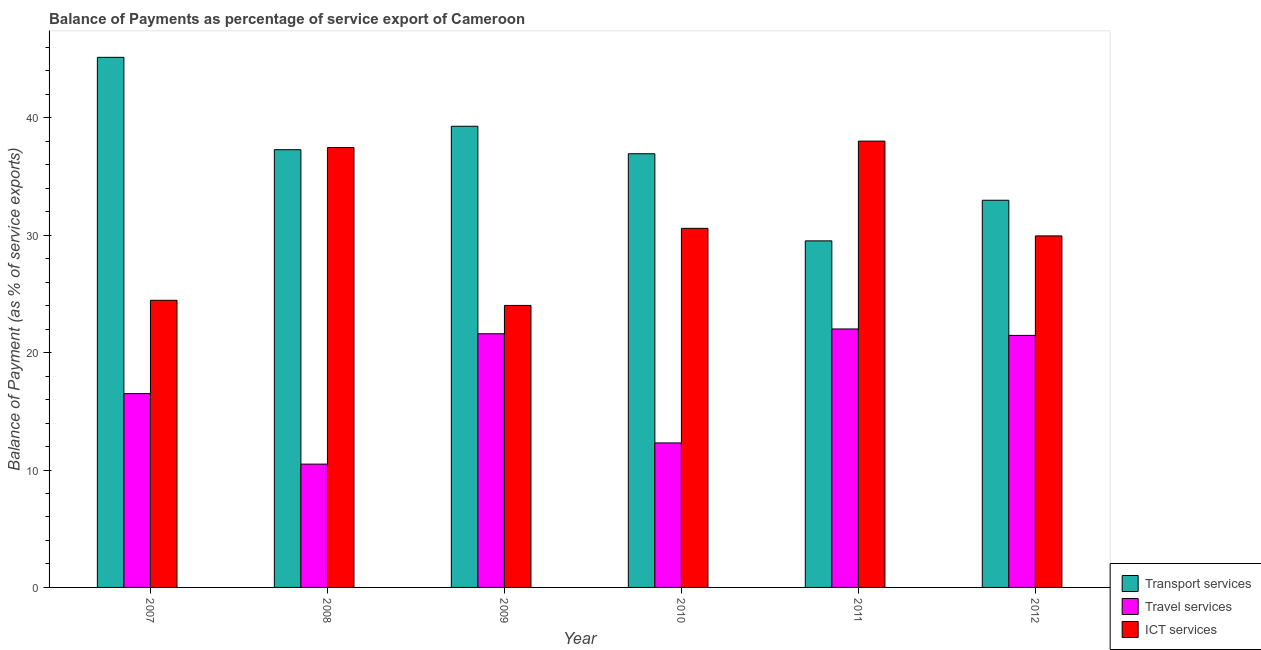How many different coloured bars are there?
Offer a terse response. 3. How many groups of bars are there?
Ensure brevity in your answer.  6. Are the number of bars per tick equal to the number of legend labels?
Make the answer very short. Yes. How many bars are there on the 2nd tick from the left?
Your response must be concise. 3. In how many cases, is the number of bars for a given year not equal to the number of legend labels?
Your answer should be compact. 0. What is the balance of payment of travel services in 2011?
Make the answer very short. 22.01. Across all years, what is the maximum balance of payment of travel services?
Offer a terse response. 22.01. Across all years, what is the minimum balance of payment of ict services?
Make the answer very short. 24.02. In which year was the balance of payment of travel services maximum?
Ensure brevity in your answer.  2011. What is the total balance of payment of ict services in the graph?
Ensure brevity in your answer.  184.48. What is the difference between the balance of payment of travel services in 2007 and that in 2009?
Make the answer very short. -5.1. What is the difference between the balance of payment of travel services in 2007 and the balance of payment of ict services in 2011?
Your response must be concise. -5.51. What is the average balance of payment of travel services per year?
Give a very brief answer. 17.4. In the year 2007, what is the difference between the balance of payment of transport services and balance of payment of travel services?
Keep it short and to the point. 0. What is the ratio of the balance of payment of travel services in 2008 to that in 2011?
Provide a short and direct response. 0.48. Is the difference between the balance of payment of transport services in 2008 and 2010 greater than the difference between the balance of payment of travel services in 2008 and 2010?
Your response must be concise. No. What is the difference between the highest and the second highest balance of payment of travel services?
Keep it short and to the point. 0.41. What is the difference between the highest and the lowest balance of payment of ict services?
Give a very brief answer. 14. In how many years, is the balance of payment of transport services greater than the average balance of payment of transport services taken over all years?
Offer a terse response. 4. What does the 2nd bar from the left in 2007 represents?
Provide a short and direct response. Travel services. What does the 2nd bar from the right in 2012 represents?
Offer a very short reply. Travel services. Is it the case that in every year, the sum of the balance of payment of transport services and balance of payment of travel services is greater than the balance of payment of ict services?
Offer a terse response. Yes. How many legend labels are there?
Ensure brevity in your answer.  3. How are the legend labels stacked?
Make the answer very short. Vertical. What is the title of the graph?
Provide a short and direct response. Balance of Payments as percentage of service export of Cameroon. Does "Hydroelectric sources" appear as one of the legend labels in the graph?
Ensure brevity in your answer.  No. What is the label or title of the X-axis?
Give a very brief answer. Year. What is the label or title of the Y-axis?
Offer a terse response. Balance of Payment (as % of service exports). What is the Balance of Payment (as % of service exports) in Transport services in 2007?
Provide a short and direct response. 45.15. What is the Balance of Payment (as % of service exports) of Travel services in 2007?
Your response must be concise. 16.51. What is the Balance of Payment (as % of service exports) in ICT services in 2007?
Give a very brief answer. 24.46. What is the Balance of Payment (as % of service exports) of Transport services in 2008?
Offer a terse response. 37.28. What is the Balance of Payment (as % of service exports) in Travel services in 2008?
Your answer should be very brief. 10.5. What is the Balance of Payment (as % of service exports) in ICT services in 2008?
Your response must be concise. 37.47. What is the Balance of Payment (as % of service exports) of Transport services in 2009?
Ensure brevity in your answer.  39.28. What is the Balance of Payment (as % of service exports) of Travel services in 2009?
Keep it short and to the point. 21.6. What is the Balance of Payment (as % of service exports) in ICT services in 2009?
Offer a terse response. 24.02. What is the Balance of Payment (as % of service exports) of Transport services in 2010?
Provide a succinct answer. 36.94. What is the Balance of Payment (as % of service exports) of Travel services in 2010?
Ensure brevity in your answer.  12.31. What is the Balance of Payment (as % of service exports) of ICT services in 2010?
Make the answer very short. 30.58. What is the Balance of Payment (as % of service exports) in Transport services in 2011?
Your answer should be very brief. 29.52. What is the Balance of Payment (as % of service exports) in Travel services in 2011?
Your response must be concise. 22.01. What is the Balance of Payment (as % of service exports) in ICT services in 2011?
Ensure brevity in your answer.  38.01. What is the Balance of Payment (as % of service exports) of Transport services in 2012?
Offer a terse response. 32.98. What is the Balance of Payment (as % of service exports) in Travel services in 2012?
Give a very brief answer. 21.46. What is the Balance of Payment (as % of service exports) in ICT services in 2012?
Offer a very short reply. 29.94. Across all years, what is the maximum Balance of Payment (as % of service exports) in Transport services?
Give a very brief answer. 45.15. Across all years, what is the maximum Balance of Payment (as % of service exports) of Travel services?
Ensure brevity in your answer.  22.01. Across all years, what is the maximum Balance of Payment (as % of service exports) in ICT services?
Provide a succinct answer. 38.01. Across all years, what is the minimum Balance of Payment (as % of service exports) of Transport services?
Provide a succinct answer. 29.52. Across all years, what is the minimum Balance of Payment (as % of service exports) of Travel services?
Your response must be concise. 10.5. Across all years, what is the minimum Balance of Payment (as % of service exports) in ICT services?
Your response must be concise. 24.02. What is the total Balance of Payment (as % of service exports) of Transport services in the graph?
Offer a very short reply. 221.15. What is the total Balance of Payment (as % of service exports) of Travel services in the graph?
Provide a succinct answer. 104.4. What is the total Balance of Payment (as % of service exports) in ICT services in the graph?
Ensure brevity in your answer.  184.48. What is the difference between the Balance of Payment (as % of service exports) of Transport services in 2007 and that in 2008?
Offer a terse response. 7.87. What is the difference between the Balance of Payment (as % of service exports) of Travel services in 2007 and that in 2008?
Your response must be concise. 6. What is the difference between the Balance of Payment (as % of service exports) of ICT services in 2007 and that in 2008?
Offer a very short reply. -13.01. What is the difference between the Balance of Payment (as % of service exports) in Transport services in 2007 and that in 2009?
Make the answer very short. 5.87. What is the difference between the Balance of Payment (as % of service exports) in Travel services in 2007 and that in 2009?
Make the answer very short. -5.1. What is the difference between the Balance of Payment (as % of service exports) of ICT services in 2007 and that in 2009?
Provide a succinct answer. 0.44. What is the difference between the Balance of Payment (as % of service exports) in Transport services in 2007 and that in 2010?
Your answer should be compact. 8.21. What is the difference between the Balance of Payment (as % of service exports) of Travel services in 2007 and that in 2010?
Your answer should be compact. 4.2. What is the difference between the Balance of Payment (as % of service exports) of ICT services in 2007 and that in 2010?
Your answer should be very brief. -6.13. What is the difference between the Balance of Payment (as % of service exports) of Transport services in 2007 and that in 2011?
Make the answer very short. 15.63. What is the difference between the Balance of Payment (as % of service exports) of Travel services in 2007 and that in 2011?
Your response must be concise. -5.51. What is the difference between the Balance of Payment (as % of service exports) of ICT services in 2007 and that in 2011?
Make the answer very short. -13.56. What is the difference between the Balance of Payment (as % of service exports) in Transport services in 2007 and that in 2012?
Your answer should be compact. 12.17. What is the difference between the Balance of Payment (as % of service exports) in Travel services in 2007 and that in 2012?
Keep it short and to the point. -4.96. What is the difference between the Balance of Payment (as % of service exports) of ICT services in 2007 and that in 2012?
Keep it short and to the point. -5.49. What is the difference between the Balance of Payment (as % of service exports) of Transport services in 2008 and that in 2009?
Offer a terse response. -2. What is the difference between the Balance of Payment (as % of service exports) in Travel services in 2008 and that in 2009?
Your response must be concise. -11.1. What is the difference between the Balance of Payment (as % of service exports) in ICT services in 2008 and that in 2009?
Your response must be concise. 13.45. What is the difference between the Balance of Payment (as % of service exports) of Transport services in 2008 and that in 2010?
Offer a terse response. 0.34. What is the difference between the Balance of Payment (as % of service exports) in Travel services in 2008 and that in 2010?
Give a very brief answer. -1.8. What is the difference between the Balance of Payment (as % of service exports) of ICT services in 2008 and that in 2010?
Provide a short and direct response. 6.88. What is the difference between the Balance of Payment (as % of service exports) in Transport services in 2008 and that in 2011?
Give a very brief answer. 7.77. What is the difference between the Balance of Payment (as % of service exports) in Travel services in 2008 and that in 2011?
Offer a very short reply. -11.51. What is the difference between the Balance of Payment (as % of service exports) of ICT services in 2008 and that in 2011?
Provide a succinct answer. -0.55. What is the difference between the Balance of Payment (as % of service exports) of Transport services in 2008 and that in 2012?
Keep it short and to the point. 4.31. What is the difference between the Balance of Payment (as % of service exports) in Travel services in 2008 and that in 2012?
Your answer should be compact. -10.96. What is the difference between the Balance of Payment (as % of service exports) of ICT services in 2008 and that in 2012?
Provide a short and direct response. 7.53. What is the difference between the Balance of Payment (as % of service exports) in Transport services in 2009 and that in 2010?
Provide a succinct answer. 2.34. What is the difference between the Balance of Payment (as % of service exports) of Travel services in 2009 and that in 2010?
Offer a very short reply. 9.3. What is the difference between the Balance of Payment (as % of service exports) of ICT services in 2009 and that in 2010?
Offer a very short reply. -6.57. What is the difference between the Balance of Payment (as % of service exports) of Transport services in 2009 and that in 2011?
Your response must be concise. 9.76. What is the difference between the Balance of Payment (as % of service exports) of Travel services in 2009 and that in 2011?
Ensure brevity in your answer.  -0.41. What is the difference between the Balance of Payment (as % of service exports) of ICT services in 2009 and that in 2011?
Offer a terse response. -14. What is the difference between the Balance of Payment (as % of service exports) in Transport services in 2009 and that in 2012?
Provide a short and direct response. 6.3. What is the difference between the Balance of Payment (as % of service exports) in Travel services in 2009 and that in 2012?
Offer a very short reply. 0.14. What is the difference between the Balance of Payment (as % of service exports) in ICT services in 2009 and that in 2012?
Your answer should be compact. -5.92. What is the difference between the Balance of Payment (as % of service exports) of Transport services in 2010 and that in 2011?
Make the answer very short. 7.42. What is the difference between the Balance of Payment (as % of service exports) of Travel services in 2010 and that in 2011?
Provide a succinct answer. -9.71. What is the difference between the Balance of Payment (as % of service exports) in ICT services in 2010 and that in 2011?
Provide a succinct answer. -7.43. What is the difference between the Balance of Payment (as % of service exports) in Transport services in 2010 and that in 2012?
Give a very brief answer. 3.96. What is the difference between the Balance of Payment (as % of service exports) in Travel services in 2010 and that in 2012?
Keep it short and to the point. -9.16. What is the difference between the Balance of Payment (as % of service exports) of ICT services in 2010 and that in 2012?
Keep it short and to the point. 0.64. What is the difference between the Balance of Payment (as % of service exports) of Transport services in 2011 and that in 2012?
Your response must be concise. -3.46. What is the difference between the Balance of Payment (as % of service exports) in Travel services in 2011 and that in 2012?
Provide a succinct answer. 0.55. What is the difference between the Balance of Payment (as % of service exports) in ICT services in 2011 and that in 2012?
Keep it short and to the point. 8.07. What is the difference between the Balance of Payment (as % of service exports) of Transport services in 2007 and the Balance of Payment (as % of service exports) of Travel services in 2008?
Your response must be concise. 34.65. What is the difference between the Balance of Payment (as % of service exports) in Transport services in 2007 and the Balance of Payment (as % of service exports) in ICT services in 2008?
Ensure brevity in your answer.  7.68. What is the difference between the Balance of Payment (as % of service exports) in Travel services in 2007 and the Balance of Payment (as % of service exports) in ICT services in 2008?
Your response must be concise. -20.96. What is the difference between the Balance of Payment (as % of service exports) of Transport services in 2007 and the Balance of Payment (as % of service exports) of Travel services in 2009?
Make the answer very short. 23.55. What is the difference between the Balance of Payment (as % of service exports) of Transport services in 2007 and the Balance of Payment (as % of service exports) of ICT services in 2009?
Offer a very short reply. 21.13. What is the difference between the Balance of Payment (as % of service exports) in Travel services in 2007 and the Balance of Payment (as % of service exports) in ICT services in 2009?
Your answer should be compact. -7.51. What is the difference between the Balance of Payment (as % of service exports) of Transport services in 2007 and the Balance of Payment (as % of service exports) of Travel services in 2010?
Keep it short and to the point. 32.84. What is the difference between the Balance of Payment (as % of service exports) in Transport services in 2007 and the Balance of Payment (as % of service exports) in ICT services in 2010?
Your answer should be very brief. 14.57. What is the difference between the Balance of Payment (as % of service exports) in Travel services in 2007 and the Balance of Payment (as % of service exports) in ICT services in 2010?
Provide a succinct answer. -14.08. What is the difference between the Balance of Payment (as % of service exports) in Transport services in 2007 and the Balance of Payment (as % of service exports) in Travel services in 2011?
Provide a succinct answer. 23.14. What is the difference between the Balance of Payment (as % of service exports) in Transport services in 2007 and the Balance of Payment (as % of service exports) in ICT services in 2011?
Provide a succinct answer. 7.14. What is the difference between the Balance of Payment (as % of service exports) in Travel services in 2007 and the Balance of Payment (as % of service exports) in ICT services in 2011?
Offer a terse response. -21.51. What is the difference between the Balance of Payment (as % of service exports) of Transport services in 2007 and the Balance of Payment (as % of service exports) of Travel services in 2012?
Ensure brevity in your answer.  23.69. What is the difference between the Balance of Payment (as % of service exports) of Transport services in 2007 and the Balance of Payment (as % of service exports) of ICT services in 2012?
Offer a very short reply. 15.21. What is the difference between the Balance of Payment (as % of service exports) in Travel services in 2007 and the Balance of Payment (as % of service exports) in ICT services in 2012?
Your response must be concise. -13.43. What is the difference between the Balance of Payment (as % of service exports) in Transport services in 2008 and the Balance of Payment (as % of service exports) in Travel services in 2009?
Make the answer very short. 15.68. What is the difference between the Balance of Payment (as % of service exports) of Transport services in 2008 and the Balance of Payment (as % of service exports) of ICT services in 2009?
Provide a succinct answer. 13.27. What is the difference between the Balance of Payment (as % of service exports) of Travel services in 2008 and the Balance of Payment (as % of service exports) of ICT services in 2009?
Offer a very short reply. -13.52. What is the difference between the Balance of Payment (as % of service exports) in Transport services in 2008 and the Balance of Payment (as % of service exports) in Travel services in 2010?
Provide a succinct answer. 24.98. What is the difference between the Balance of Payment (as % of service exports) of Transport services in 2008 and the Balance of Payment (as % of service exports) of ICT services in 2010?
Keep it short and to the point. 6.7. What is the difference between the Balance of Payment (as % of service exports) of Travel services in 2008 and the Balance of Payment (as % of service exports) of ICT services in 2010?
Your response must be concise. -20.08. What is the difference between the Balance of Payment (as % of service exports) in Transport services in 2008 and the Balance of Payment (as % of service exports) in Travel services in 2011?
Offer a terse response. 15.27. What is the difference between the Balance of Payment (as % of service exports) of Transport services in 2008 and the Balance of Payment (as % of service exports) of ICT services in 2011?
Offer a very short reply. -0.73. What is the difference between the Balance of Payment (as % of service exports) of Travel services in 2008 and the Balance of Payment (as % of service exports) of ICT services in 2011?
Offer a very short reply. -27.51. What is the difference between the Balance of Payment (as % of service exports) of Transport services in 2008 and the Balance of Payment (as % of service exports) of Travel services in 2012?
Offer a terse response. 15.82. What is the difference between the Balance of Payment (as % of service exports) in Transport services in 2008 and the Balance of Payment (as % of service exports) in ICT services in 2012?
Offer a very short reply. 7.34. What is the difference between the Balance of Payment (as % of service exports) in Travel services in 2008 and the Balance of Payment (as % of service exports) in ICT services in 2012?
Provide a short and direct response. -19.44. What is the difference between the Balance of Payment (as % of service exports) in Transport services in 2009 and the Balance of Payment (as % of service exports) in Travel services in 2010?
Give a very brief answer. 26.97. What is the difference between the Balance of Payment (as % of service exports) in Transport services in 2009 and the Balance of Payment (as % of service exports) in ICT services in 2010?
Make the answer very short. 8.7. What is the difference between the Balance of Payment (as % of service exports) in Travel services in 2009 and the Balance of Payment (as % of service exports) in ICT services in 2010?
Your answer should be very brief. -8.98. What is the difference between the Balance of Payment (as % of service exports) of Transport services in 2009 and the Balance of Payment (as % of service exports) of Travel services in 2011?
Ensure brevity in your answer.  17.27. What is the difference between the Balance of Payment (as % of service exports) in Transport services in 2009 and the Balance of Payment (as % of service exports) in ICT services in 2011?
Offer a terse response. 1.27. What is the difference between the Balance of Payment (as % of service exports) of Travel services in 2009 and the Balance of Payment (as % of service exports) of ICT services in 2011?
Your answer should be compact. -16.41. What is the difference between the Balance of Payment (as % of service exports) in Transport services in 2009 and the Balance of Payment (as % of service exports) in Travel services in 2012?
Keep it short and to the point. 17.82. What is the difference between the Balance of Payment (as % of service exports) of Transport services in 2009 and the Balance of Payment (as % of service exports) of ICT services in 2012?
Offer a terse response. 9.34. What is the difference between the Balance of Payment (as % of service exports) in Travel services in 2009 and the Balance of Payment (as % of service exports) in ICT services in 2012?
Keep it short and to the point. -8.34. What is the difference between the Balance of Payment (as % of service exports) of Transport services in 2010 and the Balance of Payment (as % of service exports) of Travel services in 2011?
Provide a short and direct response. 14.92. What is the difference between the Balance of Payment (as % of service exports) of Transport services in 2010 and the Balance of Payment (as % of service exports) of ICT services in 2011?
Provide a succinct answer. -1.08. What is the difference between the Balance of Payment (as % of service exports) in Travel services in 2010 and the Balance of Payment (as % of service exports) in ICT services in 2011?
Keep it short and to the point. -25.71. What is the difference between the Balance of Payment (as % of service exports) in Transport services in 2010 and the Balance of Payment (as % of service exports) in Travel services in 2012?
Ensure brevity in your answer.  15.47. What is the difference between the Balance of Payment (as % of service exports) in Transport services in 2010 and the Balance of Payment (as % of service exports) in ICT services in 2012?
Provide a succinct answer. 7. What is the difference between the Balance of Payment (as % of service exports) in Travel services in 2010 and the Balance of Payment (as % of service exports) in ICT services in 2012?
Keep it short and to the point. -17.63. What is the difference between the Balance of Payment (as % of service exports) of Transport services in 2011 and the Balance of Payment (as % of service exports) of Travel services in 2012?
Offer a terse response. 8.05. What is the difference between the Balance of Payment (as % of service exports) of Transport services in 2011 and the Balance of Payment (as % of service exports) of ICT services in 2012?
Offer a terse response. -0.42. What is the difference between the Balance of Payment (as % of service exports) in Travel services in 2011 and the Balance of Payment (as % of service exports) in ICT services in 2012?
Keep it short and to the point. -7.93. What is the average Balance of Payment (as % of service exports) of Transport services per year?
Make the answer very short. 36.86. What is the average Balance of Payment (as % of service exports) in Travel services per year?
Make the answer very short. 17.4. What is the average Balance of Payment (as % of service exports) of ICT services per year?
Provide a succinct answer. 30.75. In the year 2007, what is the difference between the Balance of Payment (as % of service exports) in Transport services and Balance of Payment (as % of service exports) in Travel services?
Offer a very short reply. 28.64. In the year 2007, what is the difference between the Balance of Payment (as % of service exports) in Transport services and Balance of Payment (as % of service exports) in ICT services?
Keep it short and to the point. 20.69. In the year 2007, what is the difference between the Balance of Payment (as % of service exports) of Travel services and Balance of Payment (as % of service exports) of ICT services?
Your response must be concise. -7.95. In the year 2008, what is the difference between the Balance of Payment (as % of service exports) of Transport services and Balance of Payment (as % of service exports) of Travel services?
Make the answer very short. 26.78. In the year 2008, what is the difference between the Balance of Payment (as % of service exports) in Transport services and Balance of Payment (as % of service exports) in ICT services?
Provide a short and direct response. -0.18. In the year 2008, what is the difference between the Balance of Payment (as % of service exports) of Travel services and Balance of Payment (as % of service exports) of ICT services?
Provide a succinct answer. -26.96. In the year 2009, what is the difference between the Balance of Payment (as % of service exports) of Transport services and Balance of Payment (as % of service exports) of Travel services?
Offer a very short reply. 17.68. In the year 2009, what is the difference between the Balance of Payment (as % of service exports) of Transport services and Balance of Payment (as % of service exports) of ICT services?
Your answer should be very brief. 15.26. In the year 2009, what is the difference between the Balance of Payment (as % of service exports) in Travel services and Balance of Payment (as % of service exports) in ICT services?
Give a very brief answer. -2.41. In the year 2010, what is the difference between the Balance of Payment (as % of service exports) of Transport services and Balance of Payment (as % of service exports) of Travel services?
Provide a succinct answer. 24.63. In the year 2010, what is the difference between the Balance of Payment (as % of service exports) of Transport services and Balance of Payment (as % of service exports) of ICT services?
Provide a succinct answer. 6.35. In the year 2010, what is the difference between the Balance of Payment (as % of service exports) in Travel services and Balance of Payment (as % of service exports) in ICT services?
Provide a short and direct response. -18.28. In the year 2011, what is the difference between the Balance of Payment (as % of service exports) of Transport services and Balance of Payment (as % of service exports) of Travel services?
Keep it short and to the point. 7.5. In the year 2011, what is the difference between the Balance of Payment (as % of service exports) in Transport services and Balance of Payment (as % of service exports) in ICT services?
Provide a succinct answer. -8.5. In the year 2011, what is the difference between the Balance of Payment (as % of service exports) in Travel services and Balance of Payment (as % of service exports) in ICT services?
Your response must be concise. -16. In the year 2012, what is the difference between the Balance of Payment (as % of service exports) in Transport services and Balance of Payment (as % of service exports) in Travel services?
Make the answer very short. 11.51. In the year 2012, what is the difference between the Balance of Payment (as % of service exports) of Transport services and Balance of Payment (as % of service exports) of ICT services?
Make the answer very short. 3.03. In the year 2012, what is the difference between the Balance of Payment (as % of service exports) of Travel services and Balance of Payment (as % of service exports) of ICT services?
Your answer should be very brief. -8.48. What is the ratio of the Balance of Payment (as % of service exports) of Transport services in 2007 to that in 2008?
Make the answer very short. 1.21. What is the ratio of the Balance of Payment (as % of service exports) in Travel services in 2007 to that in 2008?
Provide a short and direct response. 1.57. What is the ratio of the Balance of Payment (as % of service exports) in ICT services in 2007 to that in 2008?
Make the answer very short. 0.65. What is the ratio of the Balance of Payment (as % of service exports) in Transport services in 2007 to that in 2009?
Keep it short and to the point. 1.15. What is the ratio of the Balance of Payment (as % of service exports) of Travel services in 2007 to that in 2009?
Your answer should be compact. 0.76. What is the ratio of the Balance of Payment (as % of service exports) of ICT services in 2007 to that in 2009?
Offer a terse response. 1.02. What is the ratio of the Balance of Payment (as % of service exports) of Transport services in 2007 to that in 2010?
Make the answer very short. 1.22. What is the ratio of the Balance of Payment (as % of service exports) of Travel services in 2007 to that in 2010?
Make the answer very short. 1.34. What is the ratio of the Balance of Payment (as % of service exports) of ICT services in 2007 to that in 2010?
Ensure brevity in your answer.  0.8. What is the ratio of the Balance of Payment (as % of service exports) in Transport services in 2007 to that in 2011?
Your answer should be very brief. 1.53. What is the ratio of the Balance of Payment (as % of service exports) of Travel services in 2007 to that in 2011?
Provide a succinct answer. 0.75. What is the ratio of the Balance of Payment (as % of service exports) of ICT services in 2007 to that in 2011?
Your response must be concise. 0.64. What is the ratio of the Balance of Payment (as % of service exports) of Transport services in 2007 to that in 2012?
Provide a succinct answer. 1.37. What is the ratio of the Balance of Payment (as % of service exports) of Travel services in 2007 to that in 2012?
Your answer should be very brief. 0.77. What is the ratio of the Balance of Payment (as % of service exports) in ICT services in 2007 to that in 2012?
Make the answer very short. 0.82. What is the ratio of the Balance of Payment (as % of service exports) of Transport services in 2008 to that in 2009?
Ensure brevity in your answer.  0.95. What is the ratio of the Balance of Payment (as % of service exports) in Travel services in 2008 to that in 2009?
Your answer should be very brief. 0.49. What is the ratio of the Balance of Payment (as % of service exports) of ICT services in 2008 to that in 2009?
Offer a terse response. 1.56. What is the ratio of the Balance of Payment (as % of service exports) of Transport services in 2008 to that in 2010?
Give a very brief answer. 1.01. What is the ratio of the Balance of Payment (as % of service exports) in Travel services in 2008 to that in 2010?
Keep it short and to the point. 0.85. What is the ratio of the Balance of Payment (as % of service exports) of ICT services in 2008 to that in 2010?
Provide a succinct answer. 1.23. What is the ratio of the Balance of Payment (as % of service exports) in Transport services in 2008 to that in 2011?
Your answer should be very brief. 1.26. What is the ratio of the Balance of Payment (as % of service exports) of Travel services in 2008 to that in 2011?
Your answer should be compact. 0.48. What is the ratio of the Balance of Payment (as % of service exports) in ICT services in 2008 to that in 2011?
Make the answer very short. 0.99. What is the ratio of the Balance of Payment (as % of service exports) of Transport services in 2008 to that in 2012?
Your answer should be compact. 1.13. What is the ratio of the Balance of Payment (as % of service exports) of Travel services in 2008 to that in 2012?
Give a very brief answer. 0.49. What is the ratio of the Balance of Payment (as % of service exports) in ICT services in 2008 to that in 2012?
Offer a very short reply. 1.25. What is the ratio of the Balance of Payment (as % of service exports) in Transport services in 2009 to that in 2010?
Give a very brief answer. 1.06. What is the ratio of the Balance of Payment (as % of service exports) in Travel services in 2009 to that in 2010?
Give a very brief answer. 1.76. What is the ratio of the Balance of Payment (as % of service exports) of ICT services in 2009 to that in 2010?
Make the answer very short. 0.79. What is the ratio of the Balance of Payment (as % of service exports) in Transport services in 2009 to that in 2011?
Offer a terse response. 1.33. What is the ratio of the Balance of Payment (as % of service exports) of Travel services in 2009 to that in 2011?
Your answer should be very brief. 0.98. What is the ratio of the Balance of Payment (as % of service exports) of ICT services in 2009 to that in 2011?
Give a very brief answer. 0.63. What is the ratio of the Balance of Payment (as % of service exports) in Transport services in 2009 to that in 2012?
Offer a terse response. 1.19. What is the ratio of the Balance of Payment (as % of service exports) in ICT services in 2009 to that in 2012?
Your response must be concise. 0.8. What is the ratio of the Balance of Payment (as % of service exports) of Transport services in 2010 to that in 2011?
Your response must be concise. 1.25. What is the ratio of the Balance of Payment (as % of service exports) in Travel services in 2010 to that in 2011?
Give a very brief answer. 0.56. What is the ratio of the Balance of Payment (as % of service exports) of ICT services in 2010 to that in 2011?
Offer a terse response. 0.8. What is the ratio of the Balance of Payment (as % of service exports) of Transport services in 2010 to that in 2012?
Offer a very short reply. 1.12. What is the ratio of the Balance of Payment (as % of service exports) in Travel services in 2010 to that in 2012?
Offer a very short reply. 0.57. What is the ratio of the Balance of Payment (as % of service exports) in ICT services in 2010 to that in 2012?
Your response must be concise. 1.02. What is the ratio of the Balance of Payment (as % of service exports) of Transport services in 2011 to that in 2012?
Give a very brief answer. 0.9. What is the ratio of the Balance of Payment (as % of service exports) in Travel services in 2011 to that in 2012?
Your response must be concise. 1.03. What is the ratio of the Balance of Payment (as % of service exports) in ICT services in 2011 to that in 2012?
Your answer should be compact. 1.27. What is the difference between the highest and the second highest Balance of Payment (as % of service exports) in Transport services?
Offer a very short reply. 5.87. What is the difference between the highest and the second highest Balance of Payment (as % of service exports) of Travel services?
Your answer should be very brief. 0.41. What is the difference between the highest and the second highest Balance of Payment (as % of service exports) in ICT services?
Keep it short and to the point. 0.55. What is the difference between the highest and the lowest Balance of Payment (as % of service exports) of Transport services?
Offer a very short reply. 15.63. What is the difference between the highest and the lowest Balance of Payment (as % of service exports) in Travel services?
Offer a terse response. 11.51. What is the difference between the highest and the lowest Balance of Payment (as % of service exports) of ICT services?
Offer a terse response. 14. 